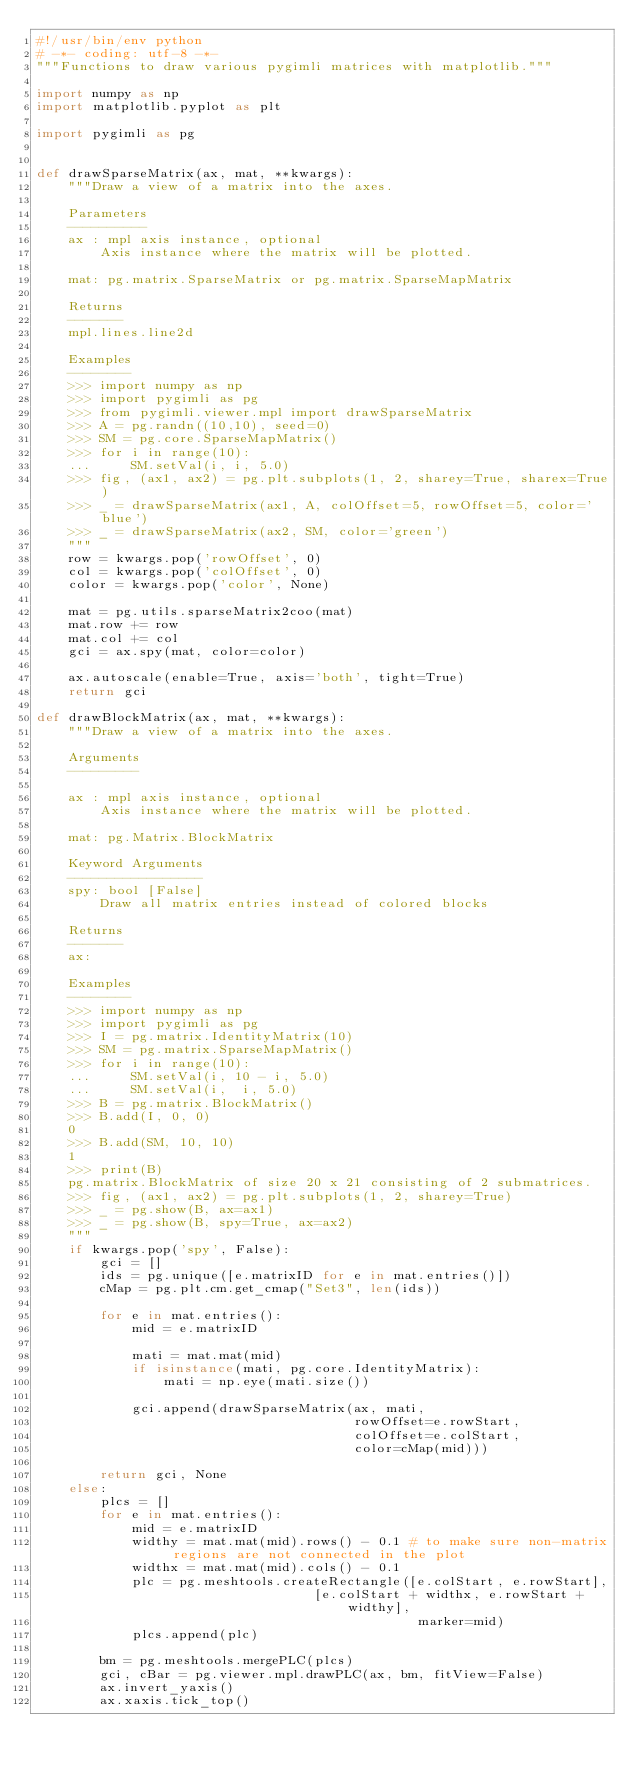Convert code to text. <code><loc_0><loc_0><loc_500><loc_500><_Python_>#!/usr/bin/env python
# -*- coding: utf-8 -*-
"""Functions to draw various pygimli matrices with matplotlib."""

import numpy as np
import matplotlib.pyplot as plt

import pygimli as pg


def drawSparseMatrix(ax, mat, **kwargs):
    """Draw a view of a matrix into the axes.

    Parameters
    ----------
    ax : mpl axis instance, optional
        Axis instance where the matrix will be plotted.

    mat: pg.matrix.SparseMatrix or pg.matrix.SparseMapMatrix

    Returns
    -------
    mpl.lines.line2d

    Examples
    --------
    >>> import numpy as np
    >>> import pygimli as pg
    >>> from pygimli.viewer.mpl import drawSparseMatrix
    >>> A = pg.randn((10,10), seed=0)
    >>> SM = pg.core.SparseMapMatrix()
    >>> for i in range(10):
    ...     SM.setVal(i, i, 5.0)
    >>> fig, (ax1, ax2) = pg.plt.subplots(1, 2, sharey=True, sharex=True)
    >>> _ = drawSparseMatrix(ax1, A, colOffset=5, rowOffset=5, color='blue')
    >>> _ = drawSparseMatrix(ax2, SM, color='green')
    """
    row = kwargs.pop('rowOffset', 0)
    col = kwargs.pop('colOffset', 0)
    color = kwargs.pop('color', None)

    mat = pg.utils.sparseMatrix2coo(mat)
    mat.row += row
    mat.col += col
    gci = ax.spy(mat, color=color)

    ax.autoscale(enable=True, axis='both', tight=True)
    return gci

def drawBlockMatrix(ax, mat, **kwargs):
    """Draw a view of a matrix into the axes.

    Arguments
    ---------

    ax : mpl axis instance, optional
        Axis instance where the matrix will be plotted.

    mat: pg.Matrix.BlockMatrix

    Keyword Arguments
    -----------------
    spy: bool [False]
        Draw all matrix entries instead of colored blocks

    Returns
    -------
    ax:

    Examples
    --------
    >>> import numpy as np
    >>> import pygimli as pg
    >>> I = pg.matrix.IdentityMatrix(10)
    >>> SM = pg.matrix.SparseMapMatrix()
    >>> for i in range(10):
    ...     SM.setVal(i, 10 - i, 5.0)
    ...     SM.setVal(i,  i, 5.0)
    >>> B = pg.matrix.BlockMatrix()
    >>> B.add(I, 0, 0)
    0
    >>> B.add(SM, 10, 10)
    1
    >>> print(B)
    pg.matrix.BlockMatrix of size 20 x 21 consisting of 2 submatrices.
    >>> fig, (ax1, ax2) = pg.plt.subplots(1, 2, sharey=True)
    >>> _ = pg.show(B, ax=ax1)
    >>> _ = pg.show(B, spy=True, ax=ax2)
    """
    if kwargs.pop('spy', False):
        gci = []
        ids = pg.unique([e.matrixID for e in mat.entries()])
        cMap = pg.plt.cm.get_cmap("Set3", len(ids))

        for e in mat.entries():
            mid = e.matrixID

            mati = mat.mat(mid)
            if isinstance(mati, pg.core.IdentityMatrix):
                mati = np.eye(mati.size())

            gci.append(drawSparseMatrix(ax, mati,
                                        rowOffset=e.rowStart,
                                        colOffset=e.colStart,
                                        color=cMap(mid)))

        return gci, None
    else:
        plcs = []
        for e in mat.entries():
            mid = e.matrixID
            widthy = mat.mat(mid).rows() - 0.1 # to make sure non-matrix regions are not connected in the plot
            widthx = mat.mat(mid).cols() - 0.1
            plc = pg.meshtools.createRectangle([e.colStart, e.rowStart],
                                   [e.colStart + widthx, e.rowStart + widthy],
                                                marker=mid)
            plcs.append(plc)

        bm = pg.meshtools.mergePLC(plcs)
        gci, cBar = pg.viewer.mpl.drawPLC(ax, bm, fitView=False)
        ax.invert_yaxis()
        ax.xaxis.tick_top()</code> 